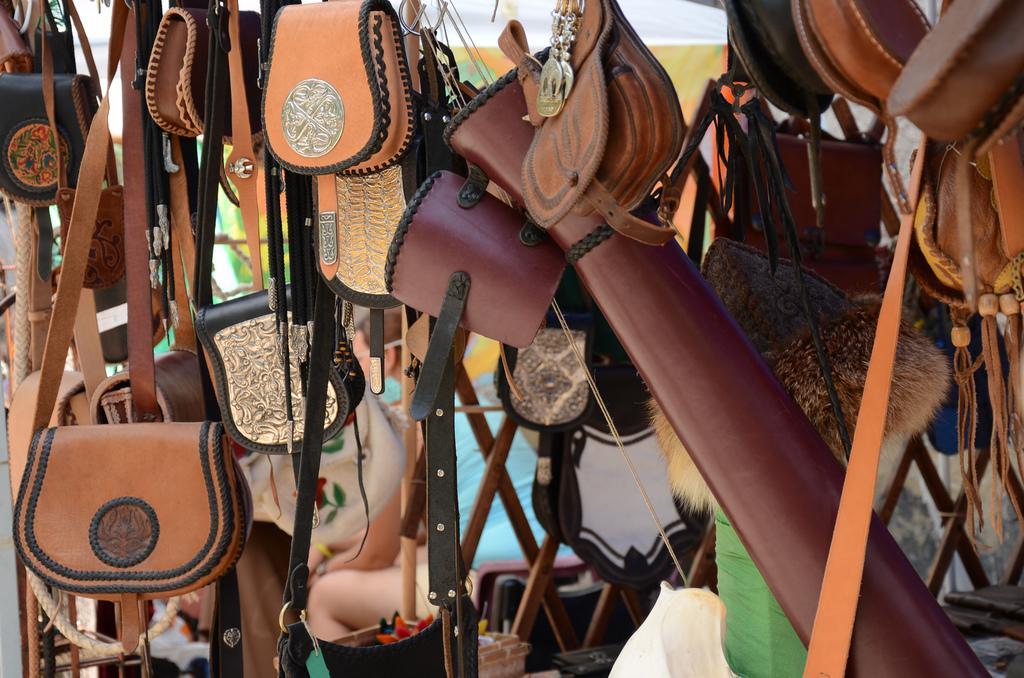How would you summarize this image in a sentence or two? In this image I can see many bags which are in brown, black and cream color. In the background I can see few people and I can also see the banner. 